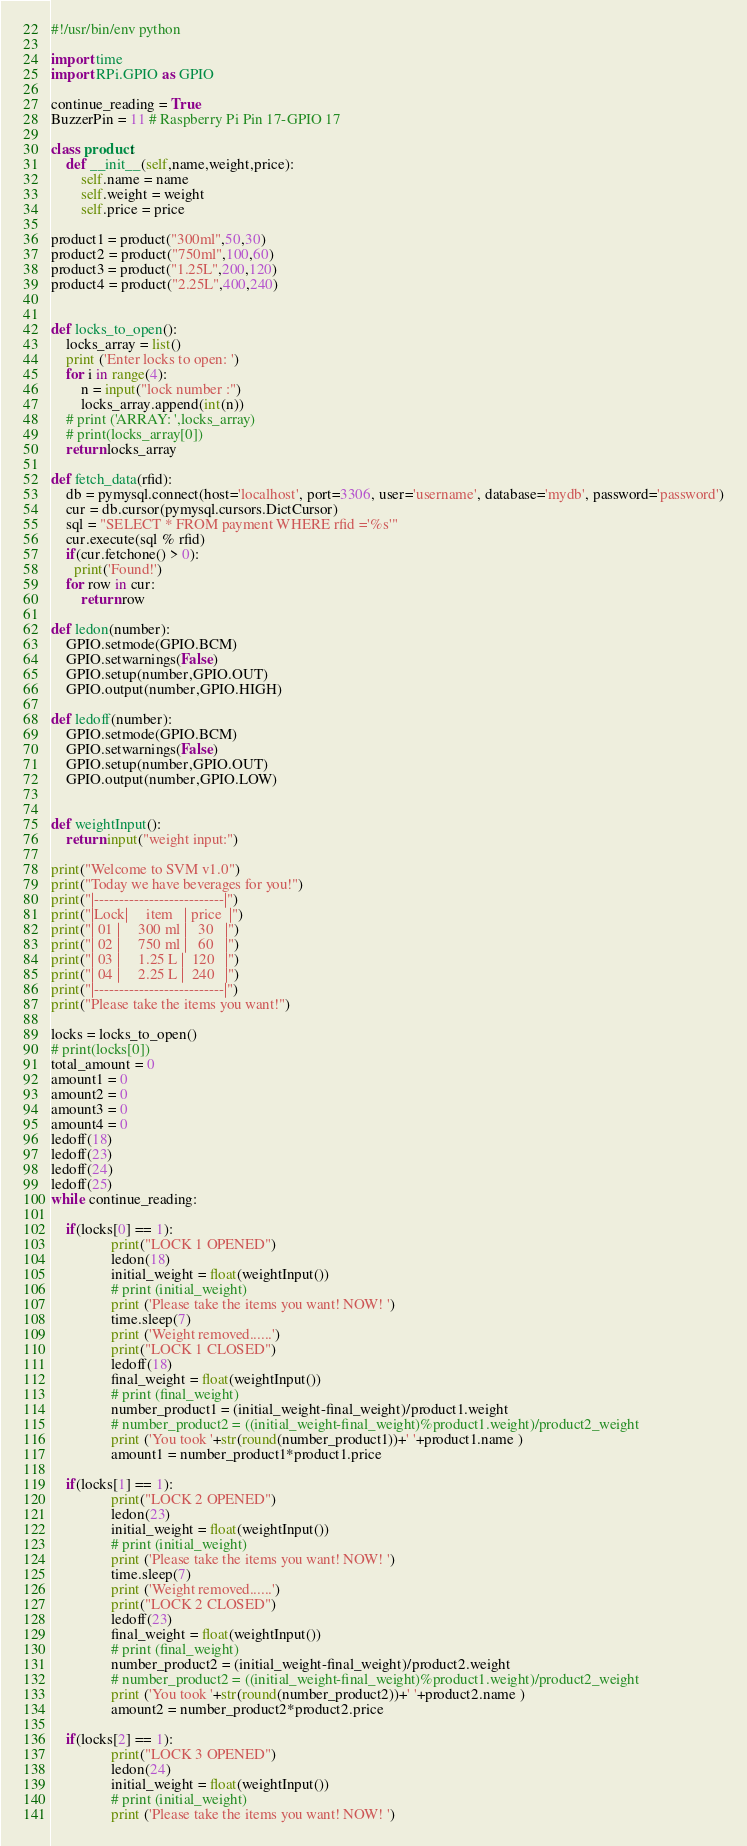Convert code to text. <code><loc_0><loc_0><loc_500><loc_500><_Python_>#!/usr/bin/env python

import time
import RPi.GPIO as GPIO

continue_reading = True
BuzzerPin = 11 # Raspberry Pi Pin 17-GPIO 17

class product:
    def __init__(self,name,weight,price):
        self.name = name
        self.weight = weight
        self.price = price

product1 = product("300ml",50,30)
product2 = product("750ml",100,60)
product3 = product("1.25L",200,120)
product4 = product("2.25L",400,240)


def locks_to_open():
    locks_array = list()
    print ('Enter locks to open: ')
    for i in range(4):
        n = input("lock number :")
        locks_array.append(int(n))
    # print ('ARRAY: ',locks_array) 
    # print(locks_array[0])
    return locks_array  

def fetch_data(rfid):
    db = pymysql.connect(host='localhost', port=3306, user='username', database='mydb', password='password')
    cur = db.cursor(pymysql.cursors.DictCursor)
    sql = "SELECT * FROM payment WHERE rfid ='%s'"
    cur.execute(sql % rfid)
    if(cur.fetchone() > 0):
      print('Found!')
    for row in cur:
        return row

def ledon(number):
    GPIO.setmode(GPIO.BCM)
    GPIO.setwarnings(False)
    GPIO.setup(number,GPIO.OUT)
    GPIO.output(number,GPIO.HIGH)

def ledoff(number):
    GPIO.setmode(GPIO.BCM)
    GPIO.setwarnings(False)
    GPIO.setup(number,GPIO.OUT)
    GPIO.output(number,GPIO.LOW)


def weightInput():
    return input("weight input:")

print("Welcome to SVM v1.0")
print("Today we have beverages for you!")
print("|--------------------------|")
print("|Lock|     item   | price  |")
print("| 01 |     300 ml |   30   |")
print("| 02 |     750 ml |   60   |")
print("| 03 |     1.25 L |  120   |")
print("| 04 |     2.25 L |  240   |")
print("|--------------------------|") 
print("Please take the items you want!")

locks = locks_to_open()
# print(locks[0])
total_amount = 0
amount1 = 0
amount2 = 0
amount3 = 0
amount4 = 0
ledoff(18)
ledoff(23)
ledoff(24)
ledoff(25)
while continue_reading:

	if(locks[0] == 1): 
         		print("LOCK 1 OPENED")
         		ledon(18)
         		initial_weight = float(weightInput())
         		# print (initial_weight)
         		print ('Please take the items you want! NOW! ')
         		time.sleep(7)
         		print ('Weight removed......')
         		print("LOCK 1 CLOSED")
         		ledoff(18)
         		final_weight = float(weightInput())
         		# print (final_weight)
         		number_product1 = (initial_weight-final_weight)/product1.weight
         		# number_product2 = ((initial_weight-final_weight)%product1.weight)/product2_weight
         		print ('You took '+str(round(number_product1))+' '+product1.name )
         		amount1 = number_product1*product1.price

	if(locks[1] == 1): 
         		print("LOCK 2 OPENED")
         		ledon(23)
         		initial_weight = float(weightInput())
         		# print (initial_weight)
         		print ('Please take the items you want! NOW! ')
         		time.sleep(7)
         		print ('Weight removed......')
         		print("LOCK 2 CLOSED")
         		ledoff(23)
         		final_weight = float(weightInput())
         		# print (final_weight)
         		number_product2 = (initial_weight-final_weight)/product2.weight
         		# number_product2 = ((initial_weight-final_weight)%product1.weight)/product2_weight
         		print ('You took '+str(round(number_product2))+' '+product2.name )
         		amount2 = number_product2*product2.price

	if(locks[2] == 1): 
         		print("LOCK 3 OPENED")
         		ledon(24)
         		initial_weight = float(weightInput())
         		# print (initial_weight)
         		print ('Please take the items you want! NOW! ')</code> 